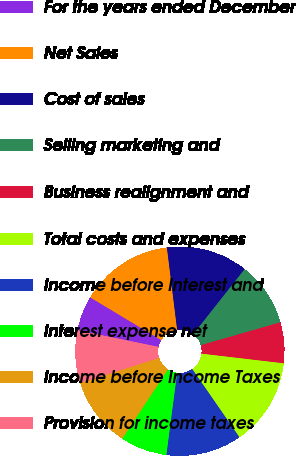Convert chart. <chart><loc_0><loc_0><loc_500><loc_500><pie_chart><fcel>For the years ended December<fcel>Net Sales<fcel>Cost of sales<fcel>Selling marketing and<fcel>Business realignment and<fcel>Total costs and expenses<fcel>Income before Interest and<fcel>Interest expense net<fcel>Income before Income Taxes<fcel>Provision for income taxes<nl><fcel>5.41%<fcel>14.41%<fcel>12.61%<fcel>9.91%<fcel>6.31%<fcel>13.51%<fcel>11.71%<fcel>7.21%<fcel>10.81%<fcel>8.11%<nl></chart> 